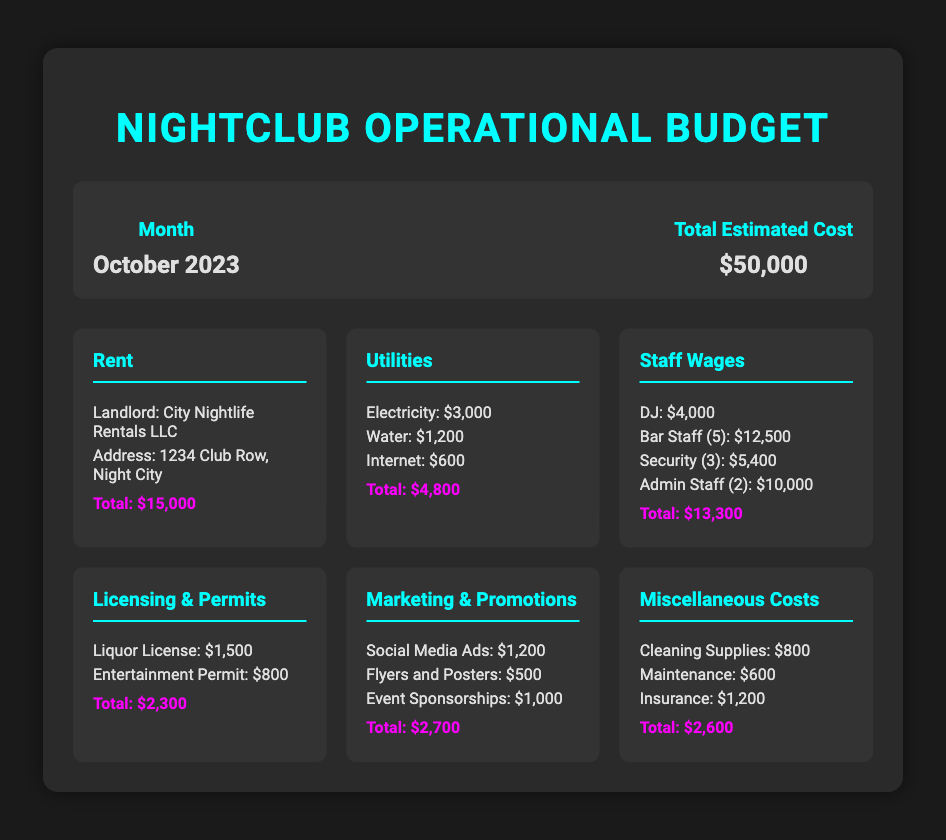What is the total estimated cost? The total estimated cost is provided in the budget summary section of the document.
Answer: $50,000 Who is the landlord? The landlord's name is mentioned in the Rent cost category.
Answer: City Nightlife Rentals LLC How much is allocated for utilities? The total for utilities can be found in the Utilities cost category by summing all utility expenses.
Answer: $4,800 What is the DJ's wage? The DJ's wage is listed under the Staff Wages cost category.
Answer: $4,000 What are the costs for miscellaneous expenses? The total for miscellaneous costs is provided in the Miscellaneous Costs category.
Answer: $2,600 How many bar staff are employed? The number of bar staff is mentioned in the Staff Wages cost category.
Answer: 5 What is the cost of the liquor license? The liquor license cost is detailed in the Licensing & Permits category.
Answer: $1,500 What is the total wage for security staff? The total wage for security staff is calculated from their individual wages listed in the Staff Wages category.
Answer: $5,400 What is the total spent on marketing and promotions? The total for marketing and promotions can be found in the Marketing & Promotions cost category.
Answer: $2,700 